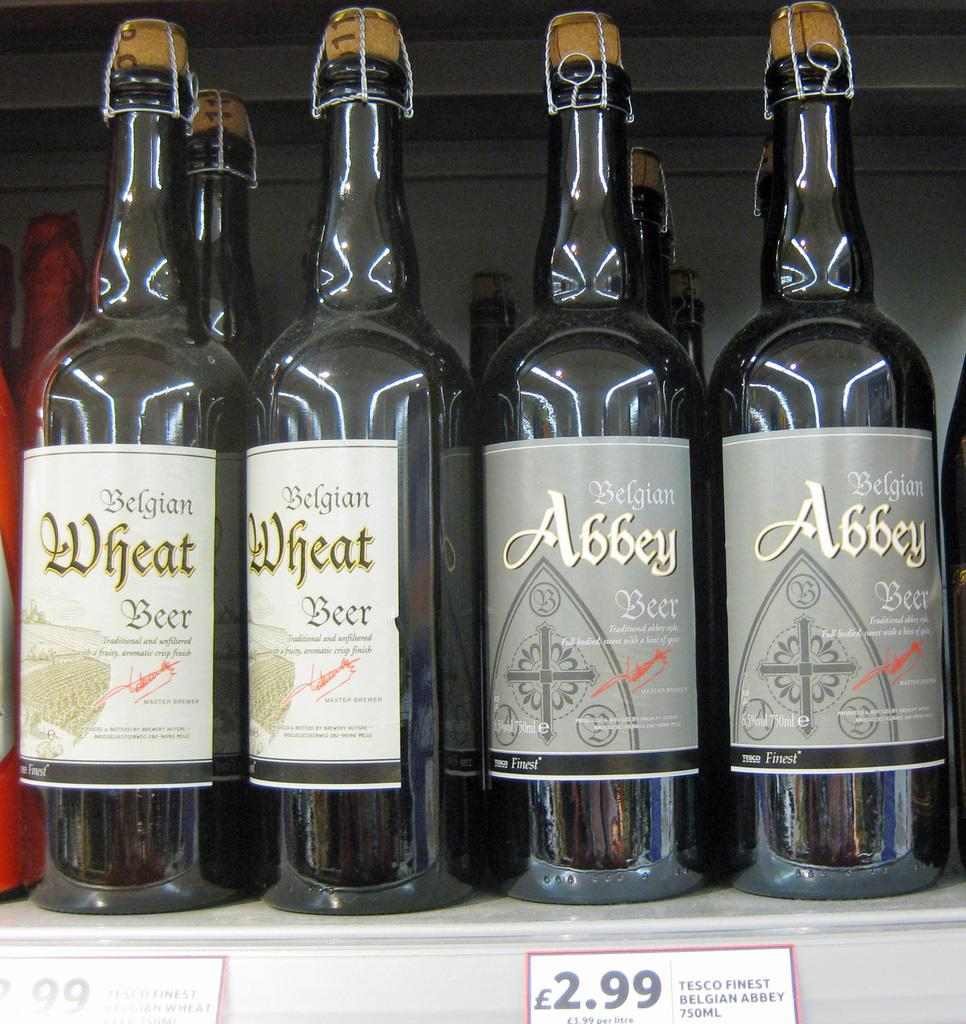<image>
Create a compact narrative representing the image presented. Bottles of Belgian Abbey beer and Belgian wheat beer. 